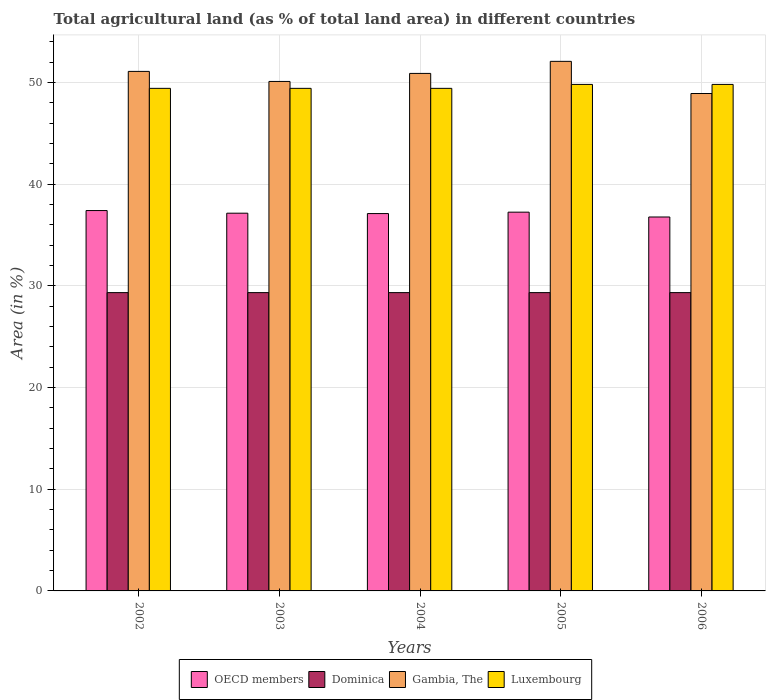How many groups of bars are there?
Provide a succinct answer. 5. Are the number of bars per tick equal to the number of legend labels?
Ensure brevity in your answer.  Yes. How many bars are there on the 1st tick from the right?
Your response must be concise. 4. What is the percentage of agricultural land in Gambia, The in 2002?
Ensure brevity in your answer.  51.09. Across all years, what is the maximum percentage of agricultural land in Luxembourg?
Make the answer very short. 49.81. Across all years, what is the minimum percentage of agricultural land in Dominica?
Provide a succinct answer. 29.33. In which year was the percentage of agricultural land in Gambia, The maximum?
Give a very brief answer. 2005. What is the total percentage of agricultural land in Gambia, The in the graph?
Ensure brevity in your answer.  253.06. What is the difference between the percentage of agricultural land in Dominica in 2004 and that in 2005?
Your response must be concise. 0. What is the difference between the percentage of agricultural land in Luxembourg in 2003 and the percentage of agricultural land in Dominica in 2006?
Offer a terse response. 20.09. What is the average percentage of agricultural land in Luxembourg per year?
Give a very brief answer. 49.58. In the year 2004, what is the difference between the percentage of agricultural land in Dominica and percentage of agricultural land in Gambia, The?
Your answer should be very brief. -21.56. What is the difference between the highest and the second highest percentage of agricultural land in Gambia, The?
Make the answer very short. 0.99. In how many years, is the percentage of agricultural land in Dominica greater than the average percentage of agricultural land in Dominica taken over all years?
Provide a short and direct response. 0. Is it the case that in every year, the sum of the percentage of agricultural land in Gambia, The and percentage of agricultural land in Dominica is greater than the sum of percentage of agricultural land in OECD members and percentage of agricultural land in Luxembourg?
Offer a terse response. No. What does the 2nd bar from the left in 2002 represents?
Provide a short and direct response. Dominica. What does the 3rd bar from the right in 2006 represents?
Your answer should be very brief. Dominica. Are all the bars in the graph horizontal?
Ensure brevity in your answer.  No. What is the difference between two consecutive major ticks on the Y-axis?
Offer a very short reply. 10. Are the values on the major ticks of Y-axis written in scientific E-notation?
Provide a short and direct response. No. Does the graph contain grids?
Your response must be concise. Yes. How are the legend labels stacked?
Make the answer very short. Horizontal. What is the title of the graph?
Offer a very short reply. Total agricultural land (as % of total land area) in different countries. Does "Ghana" appear as one of the legend labels in the graph?
Provide a short and direct response. No. What is the label or title of the Y-axis?
Provide a short and direct response. Area (in %). What is the Area (in %) in OECD members in 2002?
Provide a succinct answer. 37.4. What is the Area (in %) of Dominica in 2002?
Your answer should be very brief. 29.33. What is the Area (in %) of Gambia, The in 2002?
Offer a very short reply. 51.09. What is the Area (in %) in Luxembourg in 2002?
Your response must be concise. 49.42. What is the Area (in %) of OECD members in 2003?
Your answer should be very brief. 37.14. What is the Area (in %) in Dominica in 2003?
Offer a terse response. 29.33. What is the Area (in %) of Gambia, The in 2003?
Your answer should be very brief. 50.1. What is the Area (in %) of Luxembourg in 2003?
Your answer should be compact. 49.42. What is the Area (in %) of OECD members in 2004?
Provide a succinct answer. 37.11. What is the Area (in %) in Dominica in 2004?
Your answer should be very brief. 29.33. What is the Area (in %) in Gambia, The in 2004?
Your answer should be very brief. 50.89. What is the Area (in %) in Luxembourg in 2004?
Provide a succinct answer. 49.42. What is the Area (in %) in OECD members in 2005?
Keep it short and to the point. 37.25. What is the Area (in %) in Dominica in 2005?
Provide a succinct answer. 29.33. What is the Area (in %) of Gambia, The in 2005?
Keep it short and to the point. 52.08. What is the Area (in %) of Luxembourg in 2005?
Your answer should be very brief. 49.81. What is the Area (in %) of OECD members in 2006?
Offer a terse response. 36.77. What is the Area (in %) of Dominica in 2006?
Your answer should be compact. 29.33. What is the Area (in %) of Gambia, The in 2006?
Provide a short and direct response. 48.91. What is the Area (in %) in Luxembourg in 2006?
Make the answer very short. 49.81. Across all years, what is the maximum Area (in %) in OECD members?
Your answer should be very brief. 37.4. Across all years, what is the maximum Area (in %) in Dominica?
Your response must be concise. 29.33. Across all years, what is the maximum Area (in %) in Gambia, The?
Offer a terse response. 52.08. Across all years, what is the maximum Area (in %) in Luxembourg?
Your answer should be very brief. 49.81. Across all years, what is the minimum Area (in %) in OECD members?
Keep it short and to the point. 36.77. Across all years, what is the minimum Area (in %) of Dominica?
Your response must be concise. 29.33. Across all years, what is the minimum Area (in %) of Gambia, The?
Your answer should be very brief. 48.91. Across all years, what is the minimum Area (in %) of Luxembourg?
Ensure brevity in your answer.  49.42. What is the total Area (in %) in OECD members in the graph?
Keep it short and to the point. 185.67. What is the total Area (in %) in Dominica in the graph?
Keep it short and to the point. 146.67. What is the total Area (in %) in Gambia, The in the graph?
Provide a succinct answer. 253.06. What is the total Area (in %) in Luxembourg in the graph?
Keep it short and to the point. 247.88. What is the difference between the Area (in %) in OECD members in 2002 and that in 2003?
Make the answer very short. 0.26. What is the difference between the Area (in %) of Dominica in 2002 and that in 2003?
Make the answer very short. 0. What is the difference between the Area (in %) of Gambia, The in 2002 and that in 2003?
Make the answer very short. 0.99. What is the difference between the Area (in %) of OECD members in 2002 and that in 2004?
Offer a very short reply. 0.3. What is the difference between the Area (in %) in Gambia, The in 2002 and that in 2004?
Make the answer very short. 0.2. What is the difference between the Area (in %) of Luxembourg in 2002 and that in 2004?
Your response must be concise. 0. What is the difference between the Area (in %) of OECD members in 2002 and that in 2005?
Give a very brief answer. 0.16. What is the difference between the Area (in %) in Dominica in 2002 and that in 2005?
Make the answer very short. 0. What is the difference between the Area (in %) in Gambia, The in 2002 and that in 2005?
Your answer should be compact. -0.99. What is the difference between the Area (in %) in Luxembourg in 2002 and that in 2005?
Give a very brief answer. -0.39. What is the difference between the Area (in %) in OECD members in 2002 and that in 2006?
Your answer should be very brief. 0.63. What is the difference between the Area (in %) in Gambia, The in 2002 and that in 2006?
Offer a very short reply. 2.17. What is the difference between the Area (in %) of Luxembourg in 2002 and that in 2006?
Your response must be concise. -0.39. What is the difference between the Area (in %) in OECD members in 2003 and that in 2004?
Keep it short and to the point. 0.04. What is the difference between the Area (in %) in Gambia, The in 2003 and that in 2004?
Ensure brevity in your answer.  -0.79. What is the difference between the Area (in %) of OECD members in 2003 and that in 2005?
Make the answer very short. -0.1. What is the difference between the Area (in %) of Dominica in 2003 and that in 2005?
Make the answer very short. 0. What is the difference between the Area (in %) in Gambia, The in 2003 and that in 2005?
Your answer should be compact. -1.98. What is the difference between the Area (in %) in Luxembourg in 2003 and that in 2005?
Your answer should be very brief. -0.39. What is the difference between the Area (in %) in OECD members in 2003 and that in 2006?
Your answer should be compact. 0.37. What is the difference between the Area (in %) of Gambia, The in 2003 and that in 2006?
Offer a very short reply. 1.19. What is the difference between the Area (in %) in Luxembourg in 2003 and that in 2006?
Your answer should be compact. -0.39. What is the difference between the Area (in %) in OECD members in 2004 and that in 2005?
Give a very brief answer. -0.14. What is the difference between the Area (in %) of Gambia, The in 2004 and that in 2005?
Ensure brevity in your answer.  -1.19. What is the difference between the Area (in %) in Luxembourg in 2004 and that in 2005?
Offer a very short reply. -0.39. What is the difference between the Area (in %) of OECD members in 2004 and that in 2006?
Give a very brief answer. 0.34. What is the difference between the Area (in %) in Dominica in 2004 and that in 2006?
Keep it short and to the point. 0. What is the difference between the Area (in %) of Gambia, The in 2004 and that in 2006?
Make the answer very short. 1.98. What is the difference between the Area (in %) in Luxembourg in 2004 and that in 2006?
Your answer should be very brief. -0.39. What is the difference between the Area (in %) of OECD members in 2005 and that in 2006?
Provide a short and direct response. 0.47. What is the difference between the Area (in %) in Dominica in 2005 and that in 2006?
Give a very brief answer. 0. What is the difference between the Area (in %) in Gambia, The in 2005 and that in 2006?
Keep it short and to the point. 3.16. What is the difference between the Area (in %) in OECD members in 2002 and the Area (in %) in Dominica in 2003?
Offer a terse response. 8.07. What is the difference between the Area (in %) in OECD members in 2002 and the Area (in %) in Gambia, The in 2003?
Keep it short and to the point. -12.7. What is the difference between the Area (in %) of OECD members in 2002 and the Area (in %) of Luxembourg in 2003?
Make the answer very short. -12.02. What is the difference between the Area (in %) in Dominica in 2002 and the Area (in %) in Gambia, The in 2003?
Your answer should be compact. -20.77. What is the difference between the Area (in %) in Dominica in 2002 and the Area (in %) in Luxembourg in 2003?
Offer a very short reply. -20.09. What is the difference between the Area (in %) of Gambia, The in 2002 and the Area (in %) of Luxembourg in 2003?
Give a very brief answer. 1.67. What is the difference between the Area (in %) in OECD members in 2002 and the Area (in %) in Dominica in 2004?
Your answer should be very brief. 8.07. What is the difference between the Area (in %) in OECD members in 2002 and the Area (in %) in Gambia, The in 2004?
Provide a succinct answer. -13.49. What is the difference between the Area (in %) of OECD members in 2002 and the Area (in %) of Luxembourg in 2004?
Give a very brief answer. -12.02. What is the difference between the Area (in %) in Dominica in 2002 and the Area (in %) in Gambia, The in 2004?
Keep it short and to the point. -21.56. What is the difference between the Area (in %) in Dominica in 2002 and the Area (in %) in Luxembourg in 2004?
Ensure brevity in your answer.  -20.09. What is the difference between the Area (in %) in Gambia, The in 2002 and the Area (in %) in Luxembourg in 2004?
Make the answer very short. 1.67. What is the difference between the Area (in %) of OECD members in 2002 and the Area (in %) of Dominica in 2005?
Give a very brief answer. 8.07. What is the difference between the Area (in %) of OECD members in 2002 and the Area (in %) of Gambia, The in 2005?
Make the answer very short. -14.67. What is the difference between the Area (in %) in OECD members in 2002 and the Area (in %) in Luxembourg in 2005?
Keep it short and to the point. -12.4. What is the difference between the Area (in %) of Dominica in 2002 and the Area (in %) of Gambia, The in 2005?
Your response must be concise. -22.74. What is the difference between the Area (in %) of Dominica in 2002 and the Area (in %) of Luxembourg in 2005?
Offer a terse response. -20.47. What is the difference between the Area (in %) in Gambia, The in 2002 and the Area (in %) in Luxembourg in 2005?
Keep it short and to the point. 1.28. What is the difference between the Area (in %) of OECD members in 2002 and the Area (in %) of Dominica in 2006?
Keep it short and to the point. 8.07. What is the difference between the Area (in %) in OECD members in 2002 and the Area (in %) in Gambia, The in 2006?
Your response must be concise. -11.51. What is the difference between the Area (in %) in OECD members in 2002 and the Area (in %) in Luxembourg in 2006?
Offer a terse response. -12.4. What is the difference between the Area (in %) in Dominica in 2002 and the Area (in %) in Gambia, The in 2006?
Make the answer very short. -19.58. What is the difference between the Area (in %) of Dominica in 2002 and the Area (in %) of Luxembourg in 2006?
Your answer should be very brief. -20.47. What is the difference between the Area (in %) in Gambia, The in 2002 and the Area (in %) in Luxembourg in 2006?
Keep it short and to the point. 1.28. What is the difference between the Area (in %) in OECD members in 2003 and the Area (in %) in Dominica in 2004?
Ensure brevity in your answer.  7.81. What is the difference between the Area (in %) of OECD members in 2003 and the Area (in %) of Gambia, The in 2004?
Keep it short and to the point. -13.75. What is the difference between the Area (in %) in OECD members in 2003 and the Area (in %) in Luxembourg in 2004?
Make the answer very short. -12.28. What is the difference between the Area (in %) of Dominica in 2003 and the Area (in %) of Gambia, The in 2004?
Your response must be concise. -21.56. What is the difference between the Area (in %) of Dominica in 2003 and the Area (in %) of Luxembourg in 2004?
Offer a very short reply. -20.09. What is the difference between the Area (in %) of Gambia, The in 2003 and the Area (in %) of Luxembourg in 2004?
Offer a terse response. 0.68. What is the difference between the Area (in %) in OECD members in 2003 and the Area (in %) in Dominica in 2005?
Your response must be concise. 7.81. What is the difference between the Area (in %) in OECD members in 2003 and the Area (in %) in Gambia, The in 2005?
Your response must be concise. -14.93. What is the difference between the Area (in %) in OECD members in 2003 and the Area (in %) in Luxembourg in 2005?
Give a very brief answer. -12.66. What is the difference between the Area (in %) of Dominica in 2003 and the Area (in %) of Gambia, The in 2005?
Offer a very short reply. -22.74. What is the difference between the Area (in %) in Dominica in 2003 and the Area (in %) in Luxembourg in 2005?
Your response must be concise. -20.47. What is the difference between the Area (in %) of Gambia, The in 2003 and the Area (in %) of Luxembourg in 2005?
Your response must be concise. 0.29. What is the difference between the Area (in %) in OECD members in 2003 and the Area (in %) in Dominica in 2006?
Provide a succinct answer. 7.81. What is the difference between the Area (in %) in OECD members in 2003 and the Area (in %) in Gambia, The in 2006?
Offer a very short reply. -11.77. What is the difference between the Area (in %) of OECD members in 2003 and the Area (in %) of Luxembourg in 2006?
Your answer should be very brief. -12.66. What is the difference between the Area (in %) of Dominica in 2003 and the Area (in %) of Gambia, The in 2006?
Give a very brief answer. -19.58. What is the difference between the Area (in %) in Dominica in 2003 and the Area (in %) in Luxembourg in 2006?
Your response must be concise. -20.47. What is the difference between the Area (in %) of Gambia, The in 2003 and the Area (in %) of Luxembourg in 2006?
Give a very brief answer. 0.29. What is the difference between the Area (in %) of OECD members in 2004 and the Area (in %) of Dominica in 2005?
Offer a very short reply. 7.77. What is the difference between the Area (in %) in OECD members in 2004 and the Area (in %) in Gambia, The in 2005?
Offer a terse response. -14.97. What is the difference between the Area (in %) in OECD members in 2004 and the Area (in %) in Luxembourg in 2005?
Your response must be concise. -12.7. What is the difference between the Area (in %) in Dominica in 2004 and the Area (in %) in Gambia, The in 2005?
Keep it short and to the point. -22.74. What is the difference between the Area (in %) in Dominica in 2004 and the Area (in %) in Luxembourg in 2005?
Provide a short and direct response. -20.47. What is the difference between the Area (in %) in Gambia, The in 2004 and the Area (in %) in Luxembourg in 2005?
Make the answer very short. 1.08. What is the difference between the Area (in %) in OECD members in 2004 and the Area (in %) in Dominica in 2006?
Your answer should be very brief. 7.77. What is the difference between the Area (in %) in OECD members in 2004 and the Area (in %) in Gambia, The in 2006?
Keep it short and to the point. -11.81. What is the difference between the Area (in %) of OECD members in 2004 and the Area (in %) of Luxembourg in 2006?
Provide a succinct answer. -12.7. What is the difference between the Area (in %) in Dominica in 2004 and the Area (in %) in Gambia, The in 2006?
Make the answer very short. -19.58. What is the difference between the Area (in %) of Dominica in 2004 and the Area (in %) of Luxembourg in 2006?
Your answer should be very brief. -20.47. What is the difference between the Area (in %) of Gambia, The in 2004 and the Area (in %) of Luxembourg in 2006?
Your answer should be very brief. 1.08. What is the difference between the Area (in %) in OECD members in 2005 and the Area (in %) in Dominica in 2006?
Provide a succinct answer. 7.91. What is the difference between the Area (in %) in OECD members in 2005 and the Area (in %) in Gambia, The in 2006?
Keep it short and to the point. -11.67. What is the difference between the Area (in %) in OECD members in 2005 and the Area (in %) in Luxembourg in 2006?
Offer a terse response. -12.56. What is the difference between the Area (in %) of Dominica in 2005 and the Area (in %) of Gambia, The in 2006?
Give a very brief answer. -19.58. What is the difference between the Area (in %) in Dominica in 2005 and the Area (in %) in Luxembourg in 2006?
Your answer should be compact. -20.47. What is the difference between the Area (in %) in Gambia, The in 2005 and the Area (in %) in Luxembourg in 2006?
Offer a terse response. 2.27. What is the average Area (in %) of OECD members per year?
Your answer should be very brief. 37.13. What is the average Area (in %) in Dominica per year?
Provide a short and direct response. 29.33. What is the average Area (in %) in Gambia, The per year?
Your response must be concise. 50.61. What is the average Area (in %) in Luxembourg per year?
Your response must be concise. 49.58. In the year 2002, what is the difference between the Area (in %) in OECD members and Area (in %) in Dominica?
Provide a short and direct response. 8.07. In the year 2002, what is the difference between the Area (in %) in OECD members and Area (in %) in Gambia, The?
Offer a terse response. -13.68. In the year 2002, what is the difference between the Area (in %) in OECD members and Area (in %) in Luxembourg?
Offer a terse response. -12.02. In the year 2002, what is the difference between the Area (in %) of Dominica and Area (in %) of Gambia, The?
Provide a short and direct response. -21.75. In the year 2002, what is the difference between the Area (in %) of Dominica and Area (in %) of Luxembourg?
Give a very brief answer. -20.09. In the year 2002, what is the difference between the Area (in %) of Gambia, The and Area (in %) of Luxembourg?
Your response must be concise. 1.67. In the year 2003, what is the difference between the Area (in %) of OECD members and Area (in %) of Dominica?
Offer a very short reply. 7.81. In the year 2003, what is the difference between the Area (in %) of OECD members and Area (in %) of Gambia, The?
Make the answer very short. -12.96. In the year 2003, what is the difference between the Area (in %) in OECD members and Area (in %) in Luxembourg?
Your answer should be compact. -12.28. In the year 2003, what is the difference between the Area (in %) in Dominica and Area (in %) in Gambia, The?
Your answer should be very brief. -20.77. In the year 2003, what is the difference between the Area (in %) of Dominica and Area (in %) of Luxembourg?
Make the answer very short. -20.09. In the year 2003, what is the difference between the Area (in %) of Gambia, The and Area (in %) of Luxembourg?
Provide a succinct answer. 0.68. In the year 2004, what is the difference between the Area (in %) of OECD members and Area (in %) of Dominica?
Offer a very short reply. 7.77. In the year 2004, what is the difference between the Area (in %) of OECD members and Area (in %) of Gambia, The?
Keep it short and to the point. -13.78. In the year 2004, what is the difference between the Area (in %) of OECD members and Area (in %) of Luxembourg?
Your response must be concise. -12.31. In the year 2004, what is the difference between the Area (in %) in Dominica and Area (in %) in Gambia, The?
Your response must be concise. -21.56. In the year 2004, what is the difference between the Area (in %) in Dominica and Area (in %) in Luxembourg?
Make the answer very short. -20.09. In the year 2004, what is the difference between the Area (in %) in Gambia, The and Area (in %) in Luxembourg?
Provide a succinct answer. 1.47. In the year 2005, what is the difference between the Area (in %) of OECD members and Area (in %) of Dominica?
Provide a succinct answer. 7.91. In the year 2005, what is the difference between the Area (in %) of OECD members and Area (in %) of Gambia, The?
Your answer should be very brief. -14.83. In the year 2005, what is the difference between the Area (in %) in OECD members and Area (in %) in Luxembourg?
Your answer should be compact. -12.56. In the year 2005, what is the difference between the Area (in %) in Dominica and Area (in %) in Gambia, The?
Make the answer very short. -22.74. In the year 2005, what is the difference between the Area (in %) of Dominica and Area (in %) of Luxembourg?
Give a very brief answer. -20.47. In the year 2005, what is the difference between the Area (in %) in Gambia, The and Area (in %) in Luxembourg?
Offer a very short reply. 2.27. In the year 2006, what is the difference between the Area (in %) in OECD members and Area (in %) in Dominica?
Ensure brevity in your answer.  7.44. In the year 2006, what is the difference between the Area (in %) of OECD members and Area (in %) of Gambia, The?
Give a very brief answer. -12.14. In the year 2006, what is the difference between the Area (in %) of OECD members and Area (in %) of Luxembourg?
Your answer should be compact. -13.04. In the year 2006, what is the difference between the Area (in %) of Dominica and Area (in %) of Gambia, The?
Keep it short and to the point. -19.58. In the year 2006, what is the difference between the Area (in %) in Dominica and Area (in %) in Luxembourg?
Offer a very short reply. -20.47. In the year 2006, what is the difference between the Area (in %) of Gambia, The and Area (in %) of Luxembourg?
Your answer should be compact. -0.89. What is the ratio of the Area (in %) of Dominica in 2002 to that in 2003?
Ensure brevity in your answer.  1. What is the ratio of the Area (in %) in Gambia, The in 2002 to that in 2003?
Provide a short and direct response. 1.02. What is the ratio of the Area (in %) of OECD members in 2002 to that in 2004?
Ensure brevity in your answer.  1.01. What is the ratio of the Area (in %) in Dominica in 2002 to that in 2004?
Provide a succinct answer. 1. What is the ratio of the Area (in %) of Luxembourg in 2002 to that in 2004?
Your answer should be compact. 1. What is the ratio of the Area (in %) in Luxembourg in 2002 to that in 2005?
Ensure brevity in your answer.  0.99. What is the ratio of the Area (in %) of OECD members in 2002 to that in 2006?
Your response must be concise. 1.02. What is the ratio of the Area (in %) of Gambia, The in 2002 to that in 2006?
Keep it short and to the point. 1.04. What is the ratio of the Area (in %) in Luxembourg in 2002 to that in 2006?
Provide a short and direct response. 0.99. What is the ratio of the Area (in %) in OECD members in 2003 to that in 2004?
Your answer should be compact. 1. What is the ratio of the Area (in %) of Gambia, The in 2003 to that in 2004?
Provide a short and direct response. 0.98. What is the ratio of the Area (in %) in Dominica in 2003 to that in 2005?
Provide a succinct answer. 1. What is the ratio of the Area (in %) of Luxembourg in 2003 to that in 2005?
Offer a very short reply. 0.99. What is the ratio of the Area (in %) of OECD members in 2003 to that in 2006?
Make the answer very short. 1.01. What is the ratio of the Area (in %) in Gambia, The in 2003 to that in 2006?
Make the answer very short. 1.02. What is the ratio of the Area (in %) of Luxembourg in 2003 to that in 2006?
Your response must be concise. 0.99. What is the ratio of the Area (in %) of OECD members in 2004 to that in 2005?
Make the answer very short. 1. What is the ratio of the Area (in %) in Gambia, The in 2004 to that in 2005?
Offer a terse response. 0.98. What is the ratio of the Area (in %) of OECD members in 2004 to that in 2006?
Ensure brevity in your answer.  1.01. What is the ratio of the Area (in %) in Dominica in 2004 to that in 2006?
Provide a succinct answer. 1. What is the ratio of the Area (in %) in Gambia, The in 2004 to that in 2006?
Make the answer very short. 1.04. What is the ratio of the Area (in %) in OECD members in 2005 to that in 2006?
Keep it short and to the point. 1.01. What is the ratio of the Area (in %) in Dominica in 2005 to that in 2006?
Your answer should be very brief. 1. What is the ratio of the Area (in %) of Gambia, The in 2005 to that in 2006?
Keep it short and to the point. 1.06. What is the ratio of the Area (in %) in Luxembourg in 2005 to that in 2006?
Keep it short and to the point. 1. What is the difference between the highest and the second highest Area (in %) in OECD members?
Offer a very short reply. 0.16. What is the difference between the highest and the second highest Area (in %) of Luxembourg?
Your answer should be compact. 0. What is the difference between the highest and the lowest Area (in %) in OECD members?
Provide a short and direct response. 0.63. What is the difference between the highest and the lowest Area (in %) of Dominica?
Your answer should be very brief. 0. What is the difference between the highest and the lowest Area (in %) in Gambia, The?
Your answer should be compact. 3.16. What is the difference between the highest and the lowest Area (in %) in Luxembourg?
Make the answer very short. 0.39. 